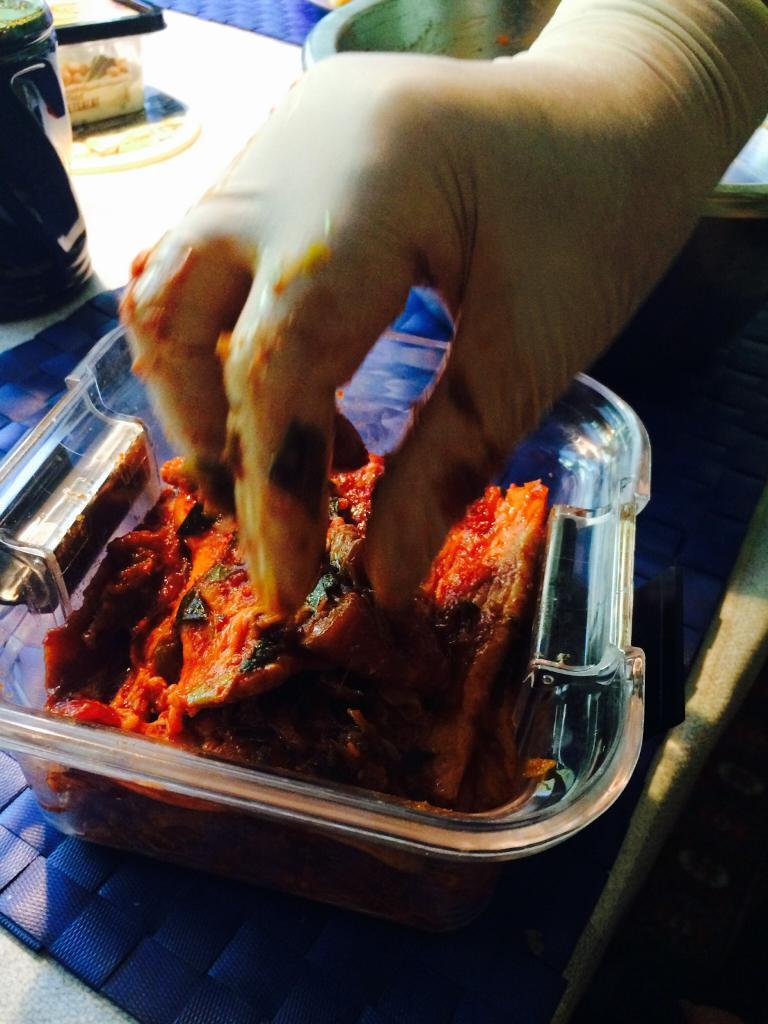Can you describe this image briefly? In this image we can see a person holding food that is placed in the container on a table. 